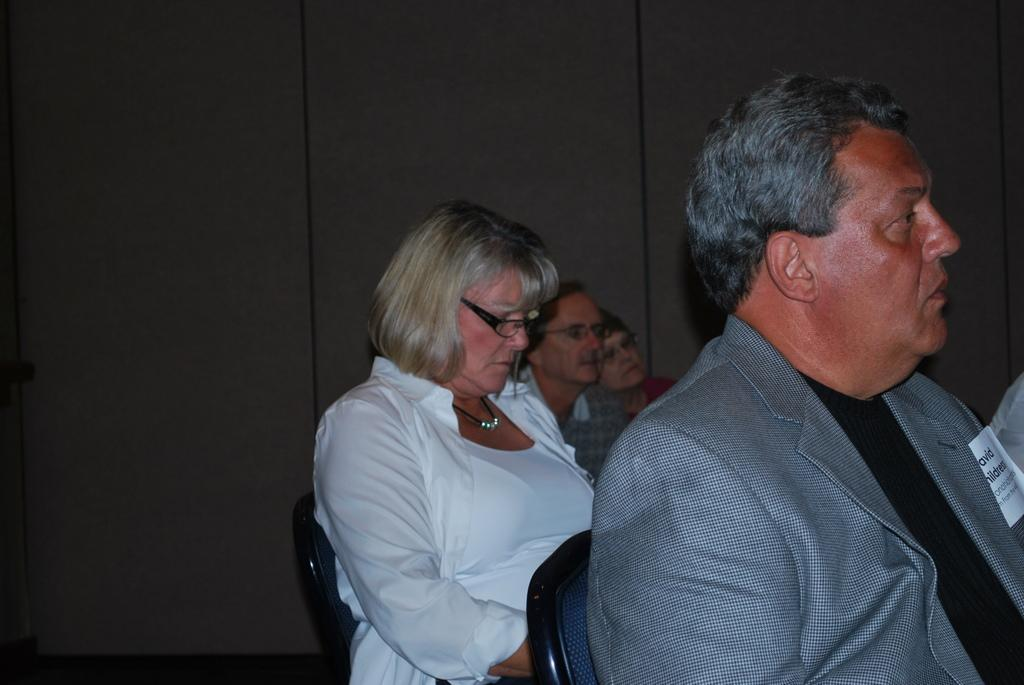What are the people in the image doing? The people in the image are sitting on chairs. Can you describe the lady sitting in the back? The lady sitting in the back is wearing a white dress, a chain, and specs. What is visible in the background of the image? There is a wall in the background of the image. What type of board is the lady using to point at the stars in the image? There is no board or stars present in the image. The lady is sitting and not pointing at anything. 